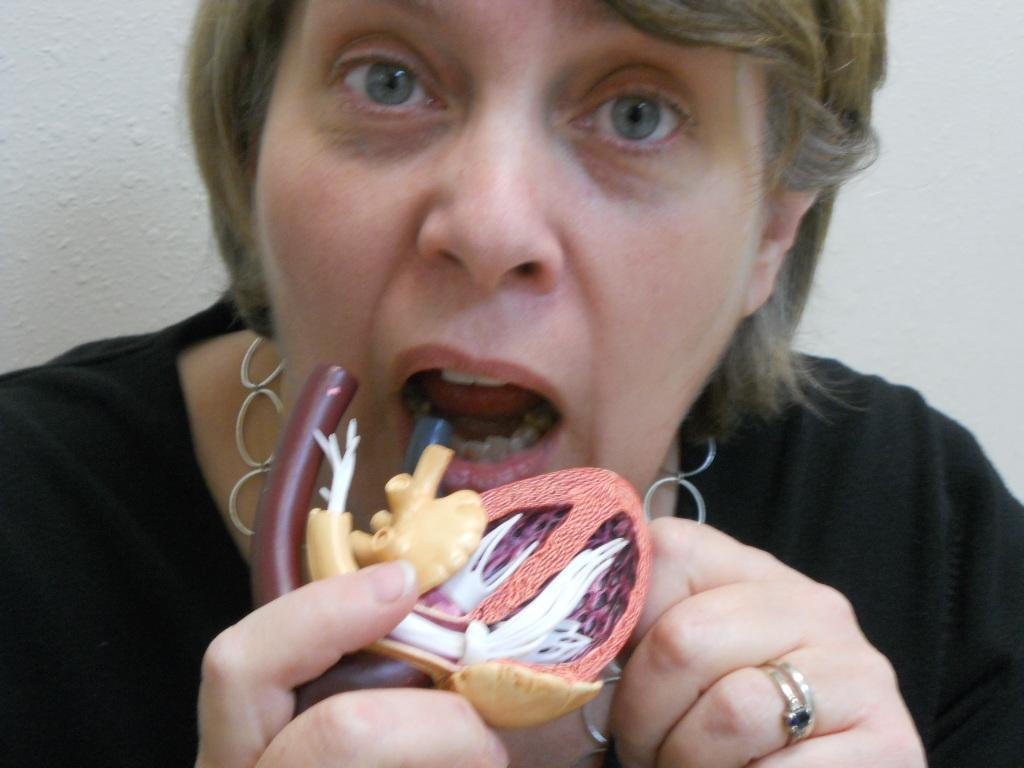What is the main subject of the image? There is a person in the image. What is the person wearing? The person is wearing a black dress. What is the person holding in the image? The person is holding a colorful object. What color is the background of the image? The background of the image is white. What type of cushion can be seen on the mountain in the image? There is no cushion or mountain present in the image. How much dust is visible on the person's black dress in the image? There is no dust visible on the person's black dress in the image. 